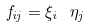Convert formula to latex. <formula><loc_0><loc_0><loc_500><loc_500>f _ { i j } = \xi _ { i } \ \eta _ { j }</formula> 